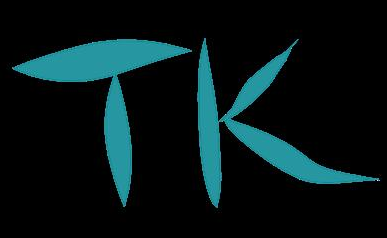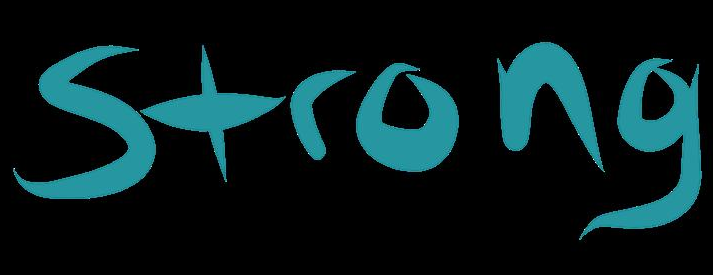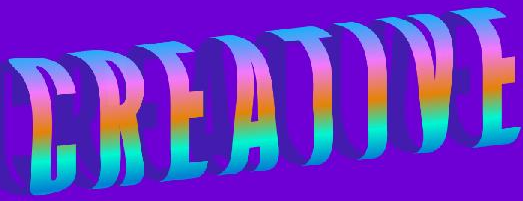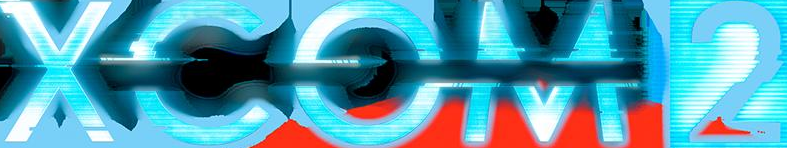What words are shown in these images in order, separated by a semicolon? TK; Strong; CREATIVE; XCOM2 